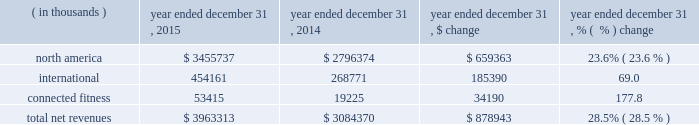Selling , general and administrative expenses increased $ 286.7 million to $ 1158.3 million in 2014 from $ 871.6 million in 2013 .
As a percentage of net revenues , selling , general and administrative expenses increased to 37.5% ( 37.5 % ) in 2014 from 37.3% ( 37.3 % ) in 2013 .
These changes were primarily attributable to the following : 2022 marketing costs increased $ 86.5 million to $ 333.0 million in 2014 from $ 246.5 million in 2013 primarily due to increased global sponsorship of professional teams and athletes .
As a percentage of net revenues , marketing costs increased to 10.8% ( 10.8 % ) in 2014 from 10.5% ( 10.5 % ) .
2022 other costs increased increased $ 200.2 million to $ 825.3 million in 2014 from $ 625.1 million in 2013 .
This increase was primarily due to higher personnel and other costs incurred for the continued expansion of our direct to consumer distribution channel , including increased investment for our brand house stores .
This increase was also due to additional investment in our connected fitness business .
As a percentage of net revenues , other costs were unchanged at 26.8% ( 26.8 % ) in 2014 and 2013 .
Income from operations increased $ 88.9 million , or 33.5% ( 33.5 % ) , to $ 354.0 million in 2014 from $ 265.1 million in 2013 .
Income from operations as a percentage of net revenues increased to 11.5% ( 11.5 % ) in 2014 from 11.4% ( 11.4 % ) in 2013 .
Interest expense , net increased $ 2.4 million to $ 5.3 million in 2014 from $ 2.9 million in 2013 .
This increase was primarily due to the $ 150.0 million and $ 100.0 million term loans borrowed during 2014 .
Other expense , net increased $ 5.2 million to $ 6.4 million in 2014 from $ 1.2 million in 2013 .
This increase was due to higher net losses in 2014 on the combined foreign currency exchange rate changes on transactions denominated in foreign currencies and our foreign currency derivative financial instruments as compared to 2013 .
Provision for income taxes increased $ 35.5 million to $ 134.2 million in 2014 from $ 98.7 million in 2013 .
Our effective tax rate was 39.2% ( 39.2 % ) in 2014 compared to 37.8% ( 37.8 % ) in 2013 .
Our effective tax rate for 2014 was higher than the effective tax rate for 2013 primarily due to increased foreign investments driving a lower proportion of foreign taxable income in 2014 and state tax credits received in 2013 .
Segment results of operations the net revenues and operating income ( loss ) associated with our segments are summarized in the tables .
The majority of corporate expenses within north america have not been allocated to international or connected fitness ; however , certain costs and revenues included within north america in the prior period have been allocated to connected fitness in the current period .
Prior period segment data has been recast by an immaterial amount within the tables to conform to the current period presentation .
Year ended december 31 , 2015 compared to year ended december 31 , 2014 net revenues by segment are summarized below: .
Net revenues in our north america operating segment increased $ 659.3 million to $ 3455.7 million in 2015 from $ 2796.4 million in 2014 primarily due to the items discussed above in the consolidated results of operations .
Net revenues in international increased $ 185.4 million to $ 454.2 million in 2015 from $ 268.8 million in 2014 primarily due to unit sales growth in our emea and asia-pacific operating segments .
Net revenues in our connected fitness operating segment increased $ 34.2 million to $ 53.4 million in 2015 from $ 19.2 million in 2014 primarily due to revenues generated from our two connected fitness acquisitions in 2015 and growth in our existing connected fitness business. .
In 2015 what was the percent of the north america to the total net revenues? 
Computations: (3455737 / 3963313)
Answer: 0.87193. Selling , general and administrative expenses increased $ 286.7 million to $ 1158.3 million in 2014 from $ 871.6 million in 2013 .
As a percentage of net revenues , selling , general and administrative expenses increased to 37.5% ( 37.5 % ) in 2014 from 37.3% ( 37.3 % ) in 2013 .
These changes were primarily attributable to the following : 2022 marketing costs increased $ 86.5 million to $ 333.0 million in 2014 from $ 246.5 million in 2013 primarily due to increased global sponsorship of professional teams and athletes .
As a percentage of net revenues , marketing costs increased to 10.8% ( 10.8 % ) in 2014 from 10.5% ( 10.5 % ) .
2022 other costs increased increased $ 200.2 million to $ 825.3 million in 2014 from $ 625.1 million in 2013 .
This increase was primarily due to higher personnel and other costs incurred for the continued expansion of our direct to consumer distribution channel , including increased investment for our brand house stores .
This increase was also due to additional investment in our connected fitness business .
As a percentage of net revenues , other costs were unchanged at 26.8% ( 26.8 % ) in 2014 and 2013 .
Income from operations increased $ 88.9 million , or 33.5% ( 33.5 % ) , to $ 354.0 million in 2014 from $ 265.1 million in 2013 .
Income from operations as a percentage of net revenues increased to 11.5% ( 11.5 % ) in 2014 from 11.4% ( 11.4 % ) in 2013 .
Interest expense , net increased $ 2.4 million to $ 5.3 million in 2014 from $ 2.9 million in 2013 .
This increase was primarily due to the $ 150.0 million and $ 100.0 million term loans borrowed during 2014 .
Other expense , net increased $ 5.2 million to $ 6.4 million in 2014 from $ 1.2 million in 2013 .
This increase was due to higher net losses in 2014 on the combined foreign currency exchange rate changes on transactions denominated in foreign currencies and our foreign currency derivative financial instruments as compared to 2013 .
Provision for income taxes increased $ 35.5 million to $ 134.2 million in 2014 from $ 98.7 million in 2013 .
Our effective tax rate was 39.2% ( 39.2 % ) in 2014 compared to 37.8% ( 37.8 % ) in 2013 .
Our effective tax rate for 2014 was higher than the effective tax rate for 2013 primarily due to increased foreign investments driving a lower proportion of foreign taxable income in 2014 and state tax credits received in 2013 .
Segment results of operations the net revenues and operating income ( loss ) associated with our segments are summarized in the tables .
The majority of corporate expenses within north america have not been allocated to international or connected fitness ; however , certain costs and revenues included within north america in the prior period have been allocated to connected fitness in the current period .
Prior period segment data has been recast by an immaterial amount within the tables to conform to the current period presentation .
Year ended december 31 , 2015 compared to year ended december 31 , 2014 net revenues by segment are summarized below: .
Net revenues in our north america operating segment increased $ 659.3 million to $ 3455.7 million in 2015 from $ 2796.4 million in 2014 primarily due to the items discussed above in the consolidated results of operations .
Net revenues in international increased $ 185.4 million to $ 454.2 million in 2015 from $ 268.8 million in 2014 primarily due to unit sales growth in our emea and asia-pacific operating segments .
Net revenues in our connected fitness operating segment increased $ 34.2 million to $ 53.4 million in 2015 from $ 19.2 million in 2014 primarily due to revenues generated from our two connected fitness acquisitions in 2015 and growth in our existing connected fitness business. .
In 2015 what was the percent of the growth in net revenues in international from 2014? 
Computations: (185.4 / 268.8)
Answer: 0.68973. 